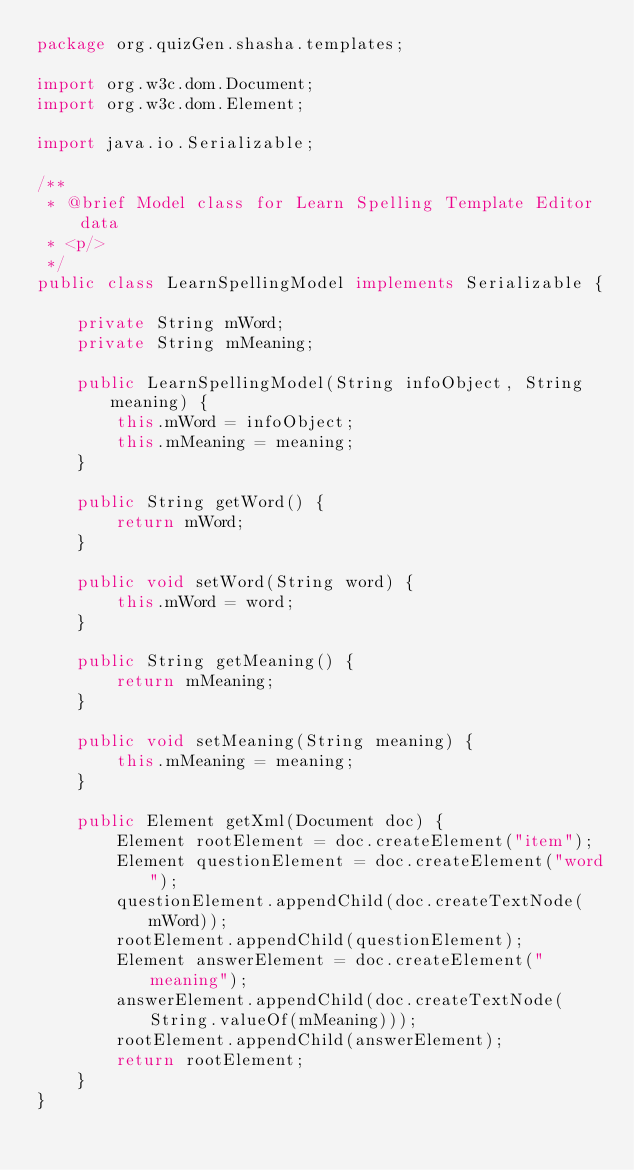<code> <loc_0><loc_0><loc_500><loc_500><_Java_>package org.quizGen.shasha.templates;

import org.w3c.dom.Document;
import org.w3c.dom.Element;

import java.io.Serializable;

/**
 * @brief Model class for Learn Spelling Template Editor data
 * <p/>
 */
public class LearnSpellingModel implements Serializable {

    private String mWord;
    private String mMeaning;

    public LearnSpellingModel(String infoObject, String meaning) {
        this.mWord = infoObject;
        this.mMeaning = meaning;
    }

    public String getWord() {
        return mWord;
    }

    public void setWord(String word) {
        this.mWord = word;
    }

    public String getMeaning() {
        return mMeaning;
    }

    public void setMeaning(String meaning) {
        this.mMeaning = meaning;
    }

    public Element getXml(Document doc) {
        Element rootElement = doc.createElement("item");
        Element questionElement = doc.createElement("word");
        questionElement.appendChild(doc.createTextNode(mWord));
        rootElement.appendChild(questionElement);
        Element answerElement = doc.createElement("meaning");
        answerElement.appendChild(doc.createTextNode(String.valueOf(mMeaning)));
        rootElement.appendChild(answerElement);
        return rootElement;
    }
}
</code> 